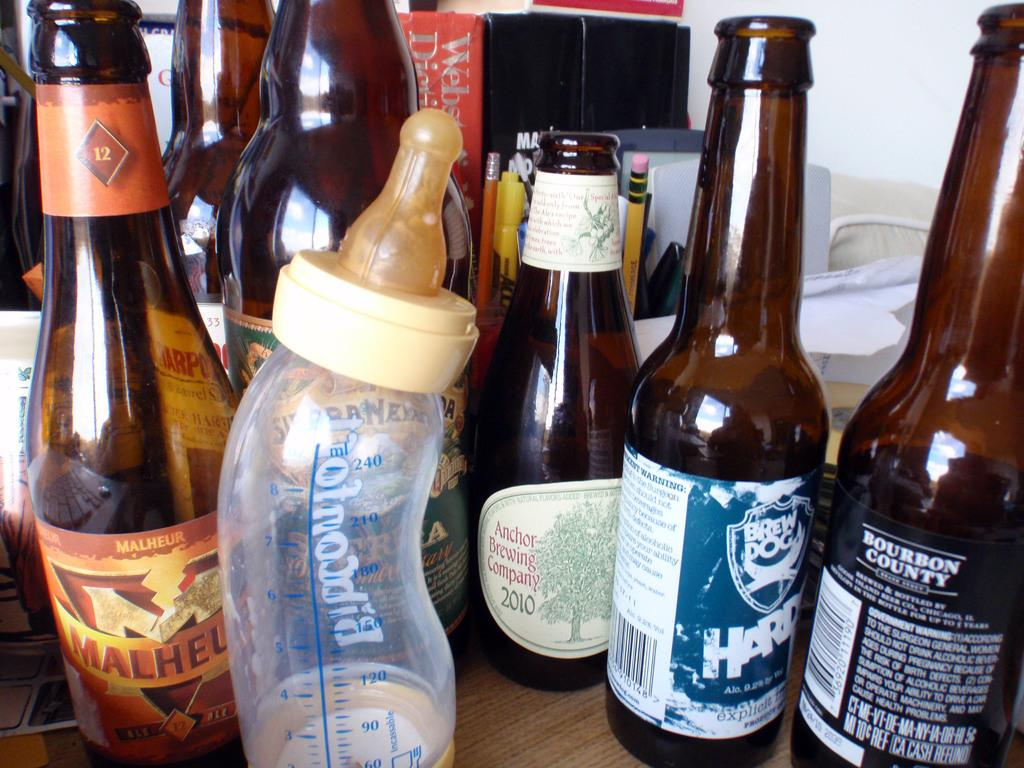<image>
Offer a succinct explanation of the picture presented. Baby bottle to the side of a brown bottle marked Anchor Brewing Company 2010. 